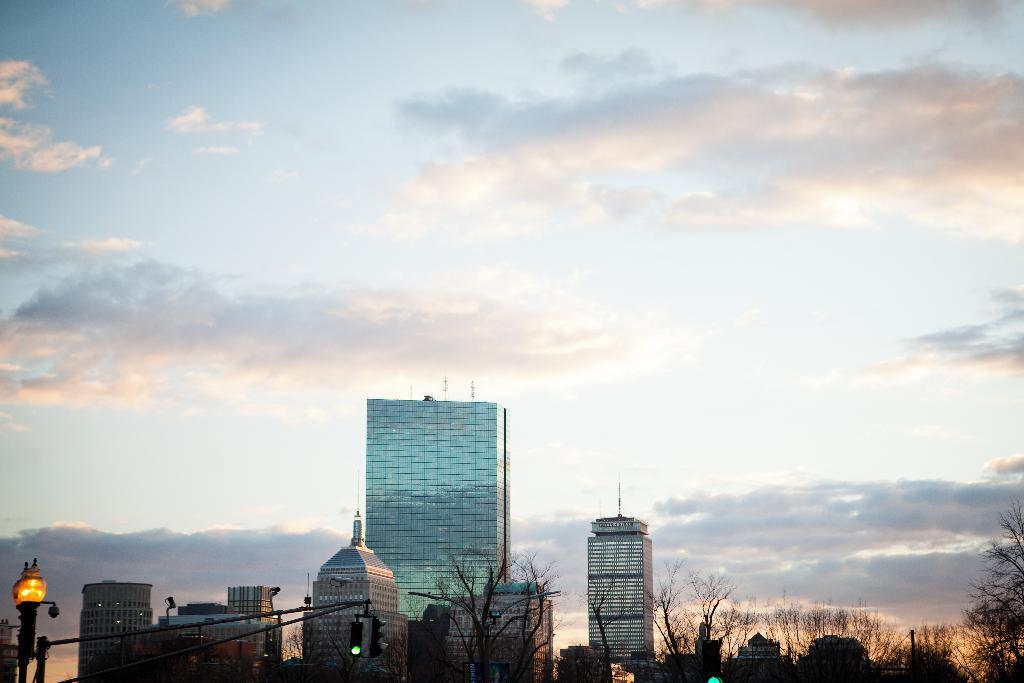What type of structures are located at the bottom of the picture? There are trees, buildings, a pole, and a street light at the bottom of the picture. What can be seen in the sky at the top of the picture? The sky is visible at the top of the picture. What type of cub is playing with a spade in the image? There is no cub or spade present in the image; it features trees, buildings, a pole, and a street light at the bottom, with the sky visible at the top. 